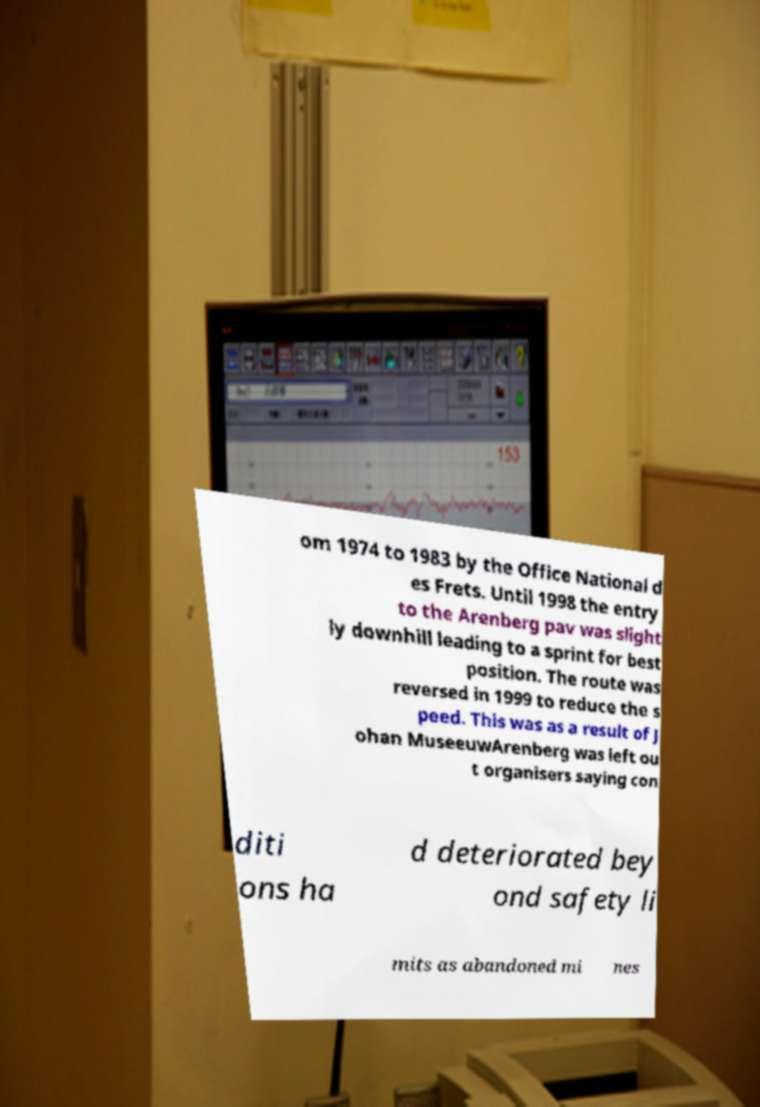I need the written content from this picture converted into text. Can you do that? om 1974 to 1983 by the Office National d es Frets. Until 1998 the entry to the Arenberg pav was slight ly downhill leading to a sprint for best position. The route was reversed in 1999 to reduce the s peed. This was as a result of J ohan MuseeuwArenberg was left ou t organisers saying con diti ons ha d deteriorated bey ond safety li mits as abandoned mi nes 